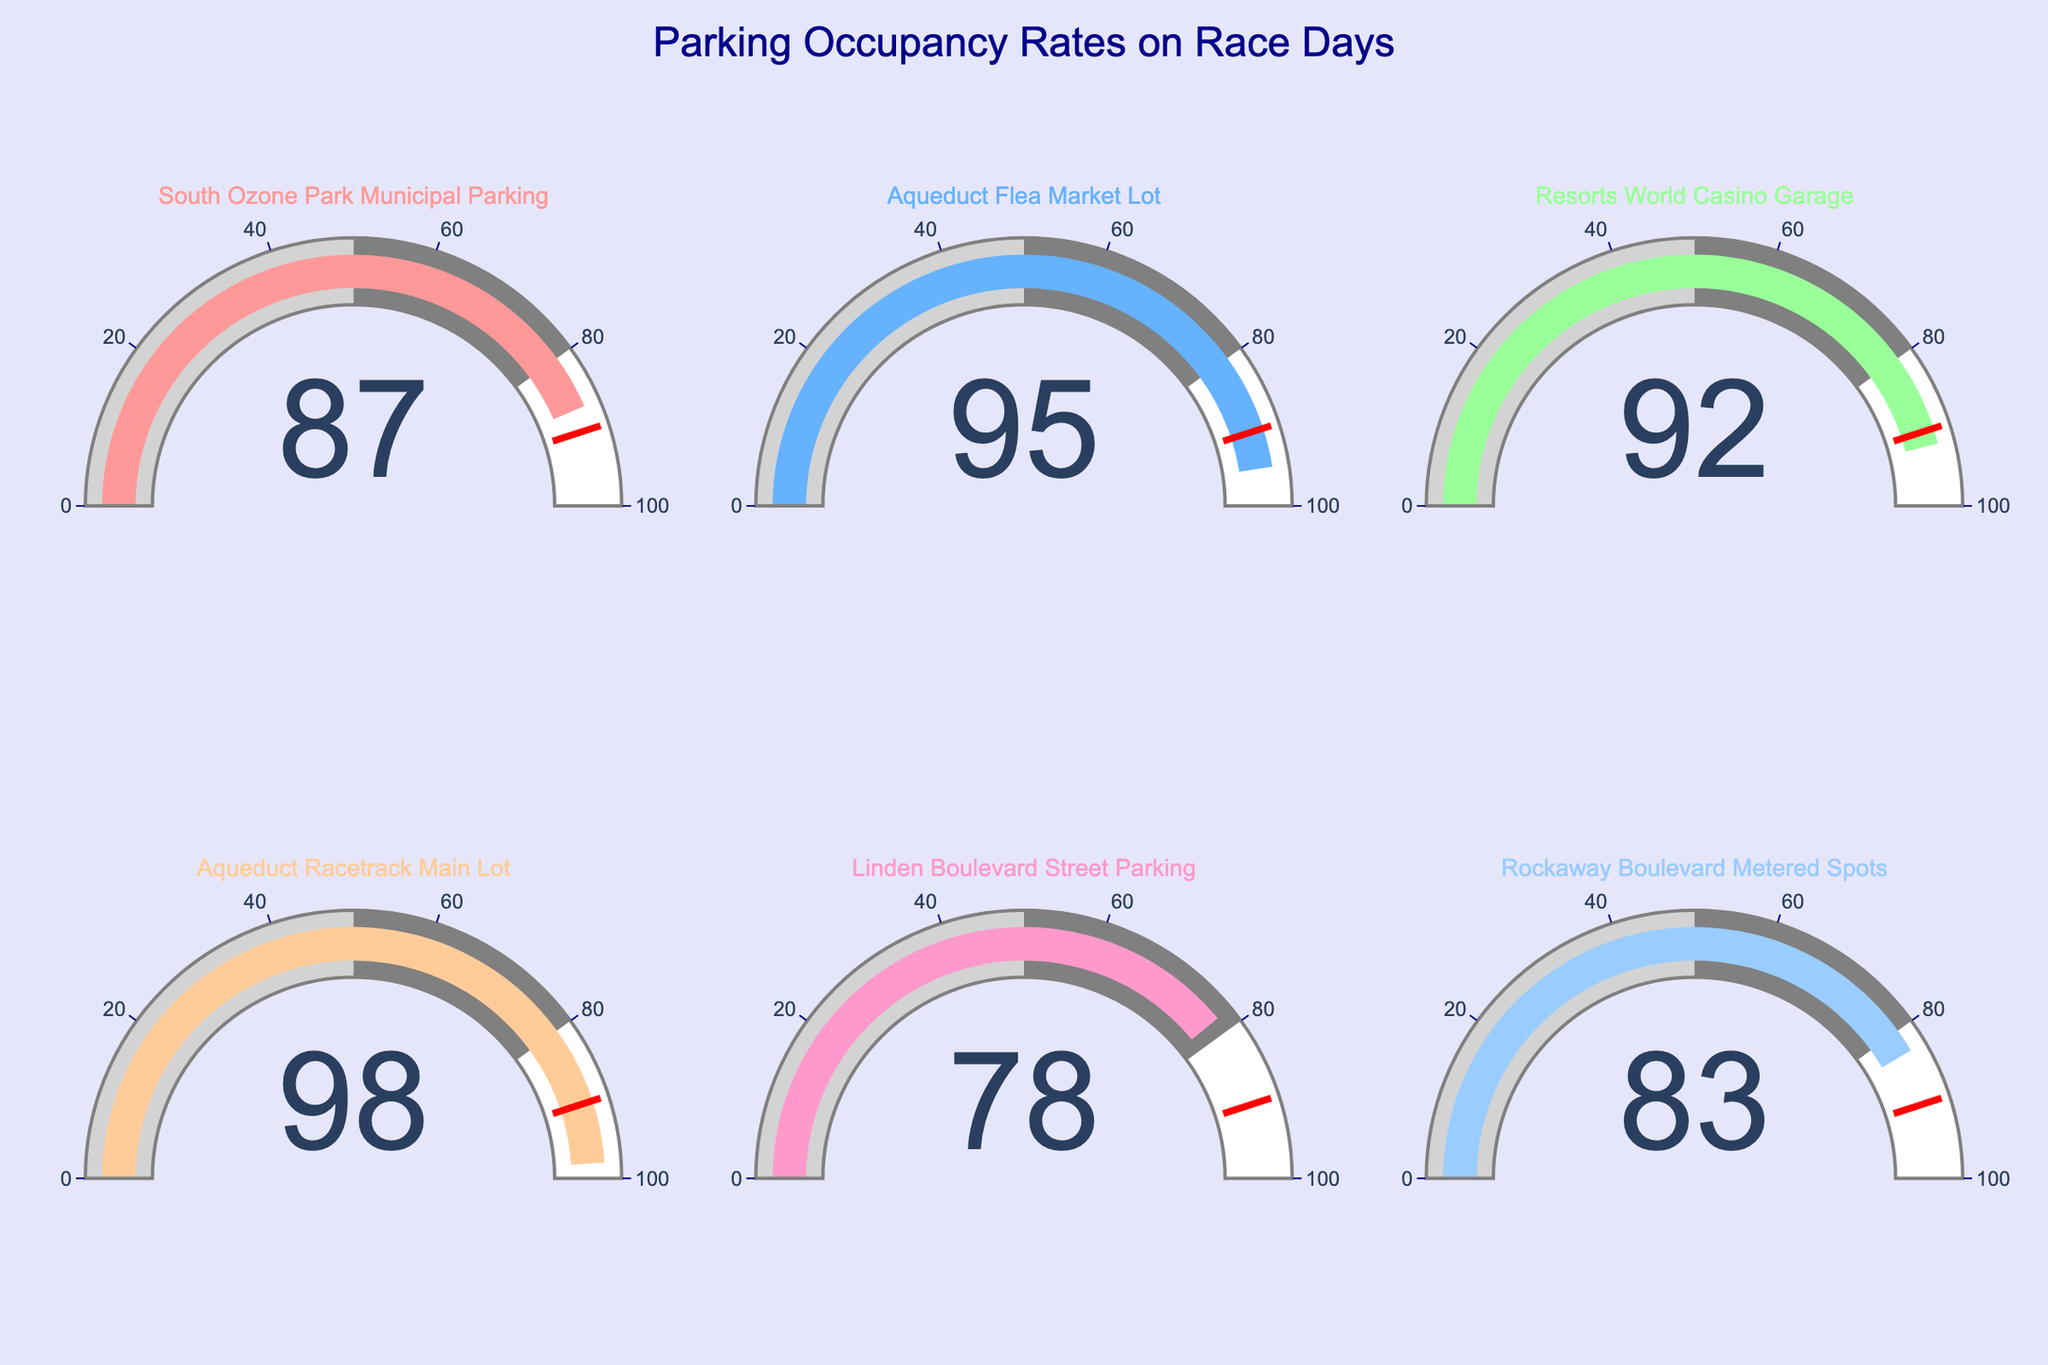What's the highest occupancy rate shown in the figure? Look at the values presented on each gauge. The highest number displayed is the highest occupancy rate.
Answer: 98 Which parking facility has the lowest occupancy rate? By examining each gauge, the lowest value represented is the lowest occupancy rate.
Answer: Linden Boulevard Street Parking What's the average occupancy rate of all the plotted facilities? Sum all the occupancy rates (87 + 95 + 92 + 98 + 78 + 83 = 533) and divide by the number of locations (6).
Answer: 88.83 How many parking facilities have an occupancy rate above 90%? Identify each gauge with numbers greater than 90 (three facilities: Aqueduct Flea Market Lot, Resorts World Casino Garage, Aqueduct Racetrack Main Lot).
Answer: 3 Which facility surpasses the threshold of 90% occupancy set in the gauges? Look at which gauges exceed the threshold line marked at 90%; facilities with values above it qualify.
Answer: South Ozone Park Municipal Parking, Aqueduct Flea Market Lot, Resorts World Casino Garage, Aqueduct Racetrack Main Lot If we combine the occupancy rates of Rockaway Boulevard Metered Spots and South Ozone Park Municipal Parking, what is the sum? Add the occupancy rates of the two locations (83 + 87).
Answer: 170 Which facility has an occupancy rate closest to the median value of all provided rates? Arrange the rates (78, 83, 87, 92, 95, 98) and find the median (average of the middle two values, 87 and 92). Then identify the closest value.
Answer: South Ozone Park Municipal Parking Is the occupancy rate of Aqueduct Racetrack Main Lot greater than Resorts World Casino Garage? Compare the numbers on both gauges.
Answer: Yes How much higher is the occupancy rate of Aqueduct Racetrack Main Lot compared to Linden Boulevard Street Parking? Subtract the occupancy rate of Linden Boulevard Street Parking from that of Aqueduct Racetrack Main Lot (98 - 78).
Answer: 20 Which colored gauge represents the highest occupancy rate? Locate the gauge with the highest number and note its color.
Answer: The pink gauge 